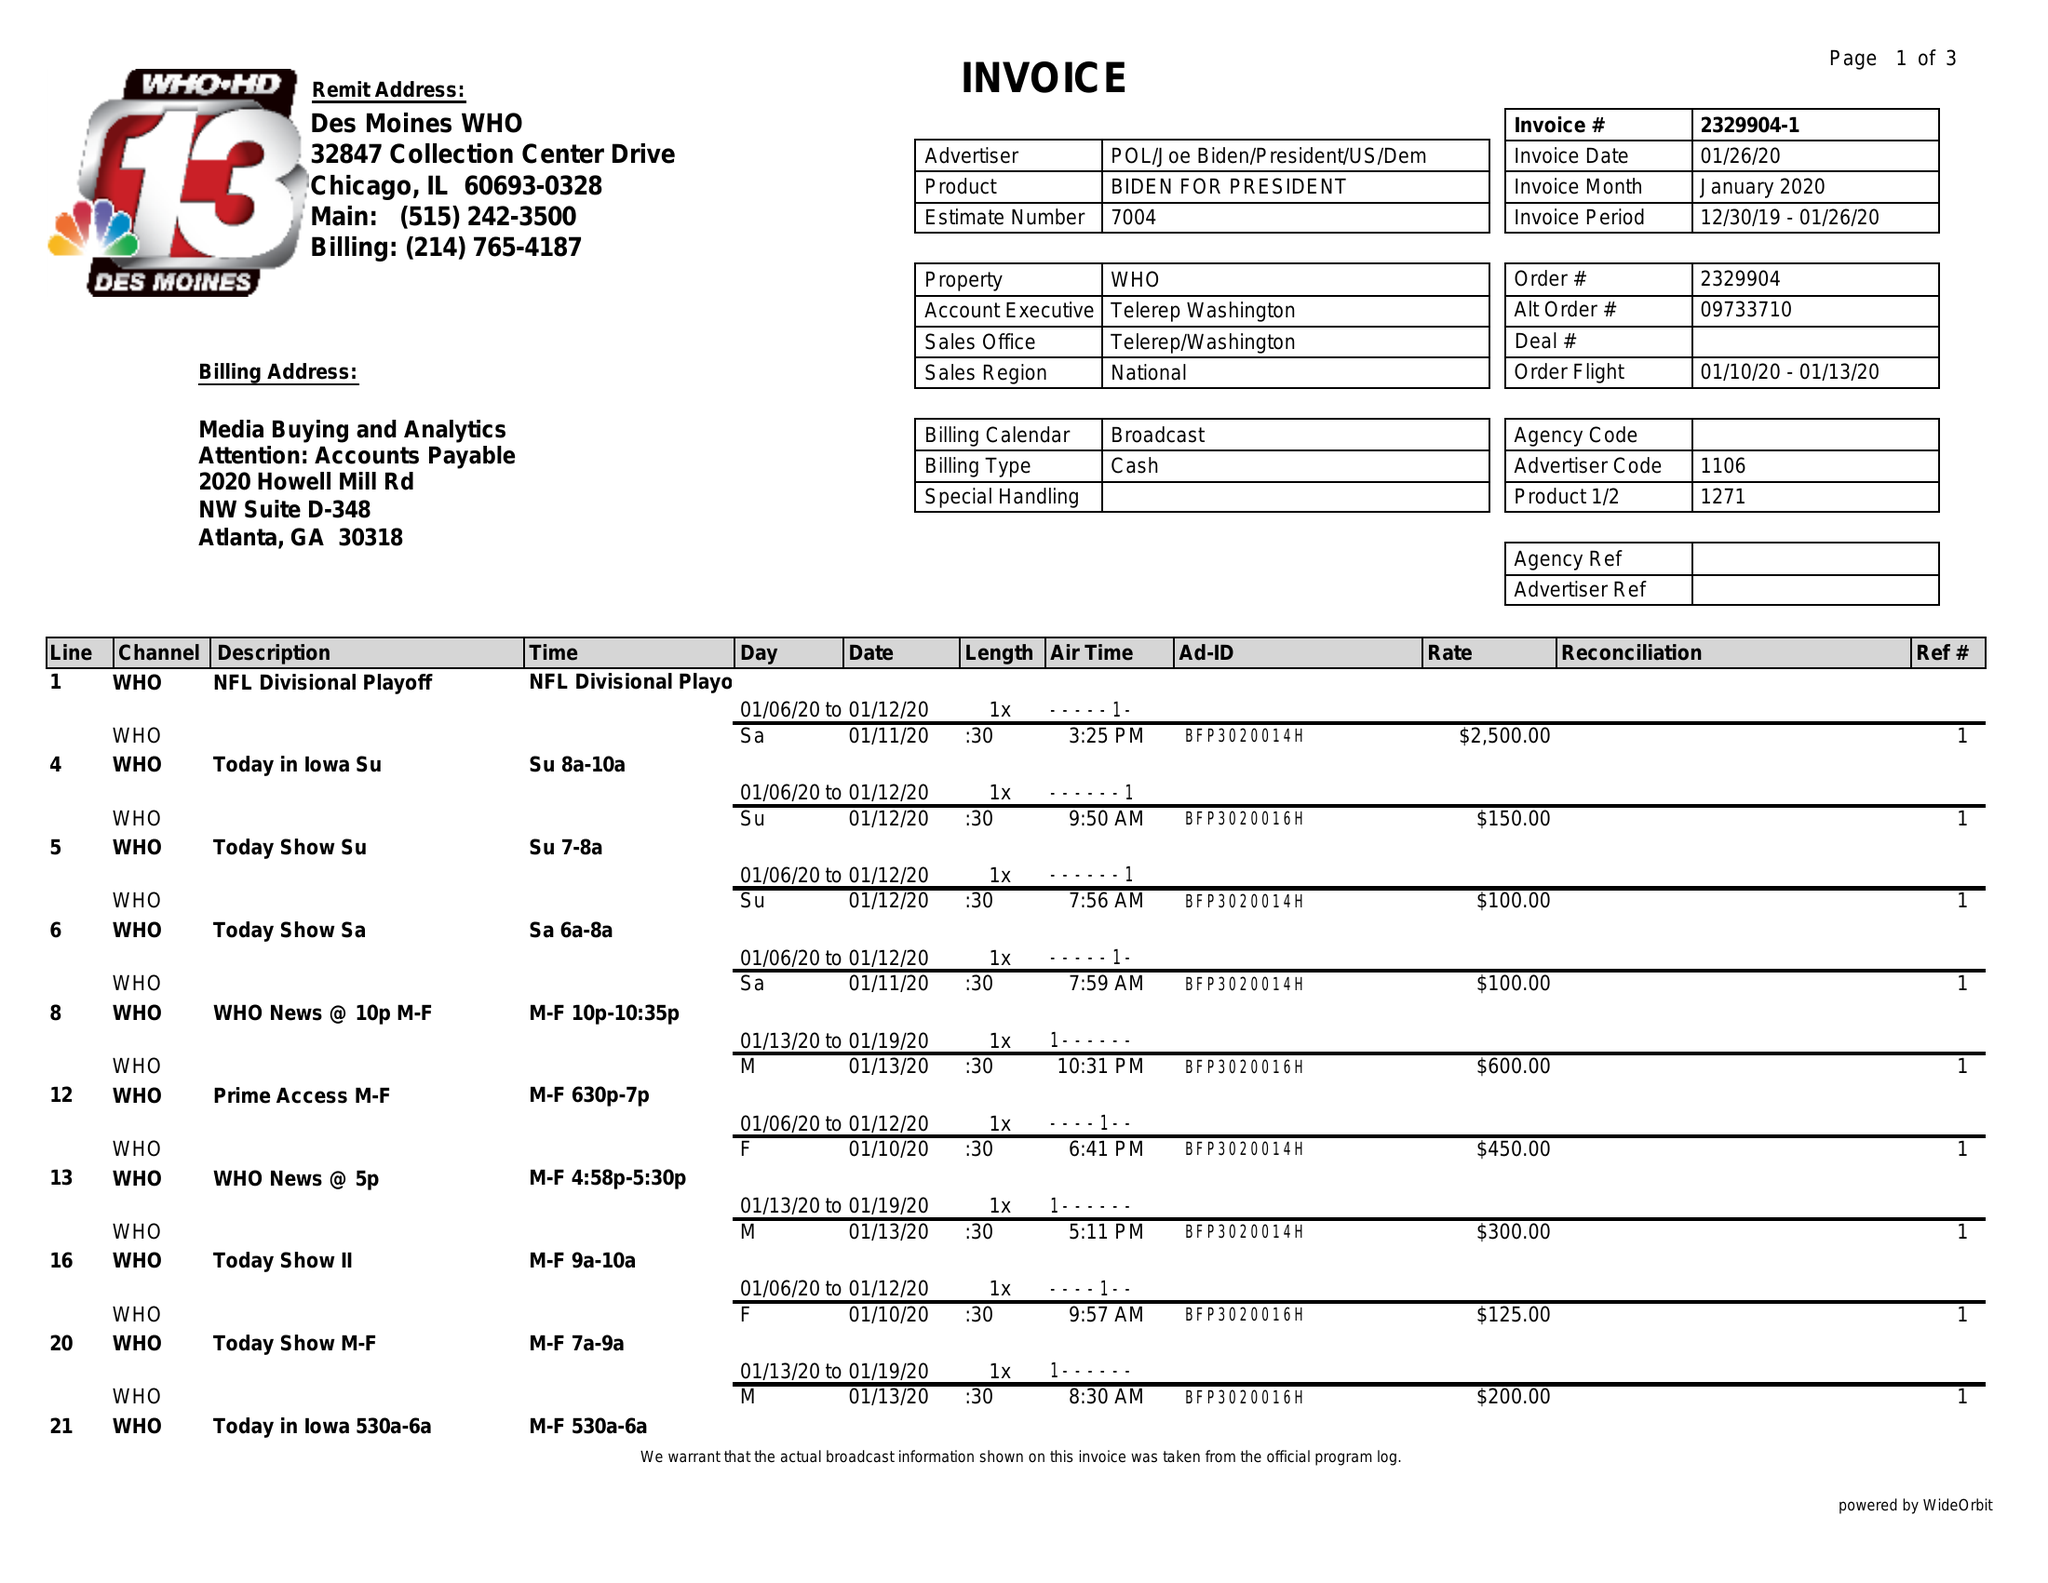What is the value for the contract_num?
Answer the question using a single word or phrase. 2329904 